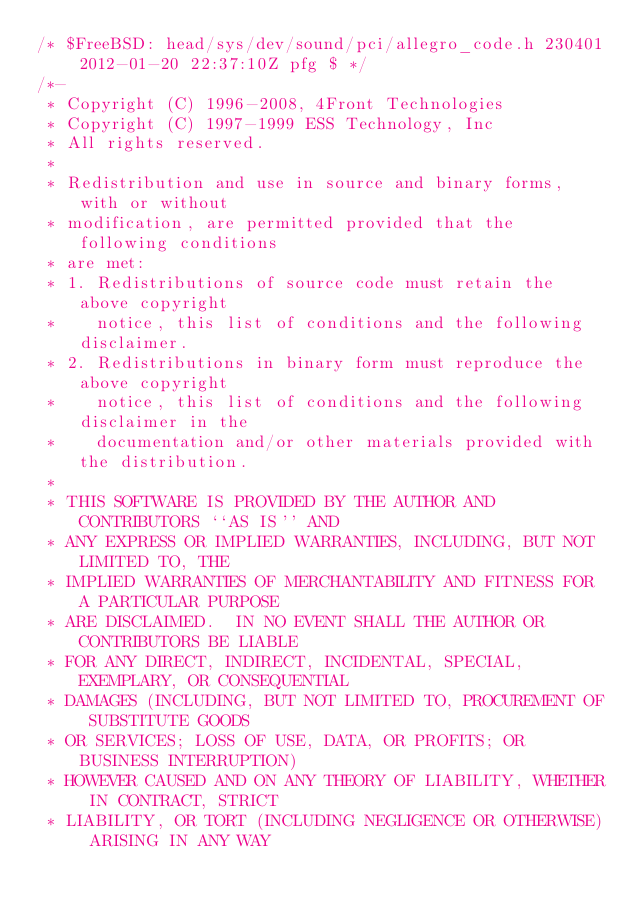Convert code to text. <code><loc_0><loc_0><loc_500><loc_500><_C_>/* $FreeBSD: head/sys/dev/sound/pci/allegro_code.h 230401 2012-01-20 22:37:10Z pfg $ */
/*-
 * Copyright (C) 1996-2008, 4Front Technologies
 * Copyright (C) 1997-1999 ESS Technology, Inc
 * All rights reserved.
 *
 * Redistribution and use in source and binary forms, with or without
 * modification, are permitted provided that the following conditions
 * are met:
 * 1. Redistributions of source code must retain the above copyright
 *    notice, this list of conditions and the following disclaimer.
 * 2. Redistributions in binary form must reproduce the above copyright
 *    notice, this list of conditions and the following disclaimer in the
 *    documentation and/or other materials provided with the distribution.
 *
 * THIS SOFTWARE IS PROVIDED BY THE AUTHOR AND CONTRIBUTORS ``AS IS'' AND
 * ANY EXPRESS OR IMPLIED WARRANTIES, INCLUDING, BUT NOT LIMITED TO, THE
 * IMPLIED WARRANTIES OF MERCHANTABILITY AND FITNESS FOR A PARTICULAR PURPOSE
 * ARE DISCLAIMED.  IN NO EVENT SHALL THE AUTHOR OR CONTRIBUTORS BE LIABLE
 * FOR ANY DIRECT, INDIRECT, INCIDENTAL, SPECIAL, EXEMPLARY, OR CONSEQUENTIAL
 * DAMAGES (INCLUDING, BUT NOT LIMITED TO, PROCUREMENT OF SUBSTITUTE GOODS
 * OR SERVICES; LOSS OF USE, DATA, OR PROFITS; OR BUSINESS INTERRUPTION)
 * HOWEVER CAUSED AND ON ANY THEORY OF LIABILITY, WHETHER IN CONTRACT, STRICT
 * LIABILITY, OR TORT (INCLUDING NEGLIGENCE OR OTHERWISE) ARISING IN ANY WAY</code> 